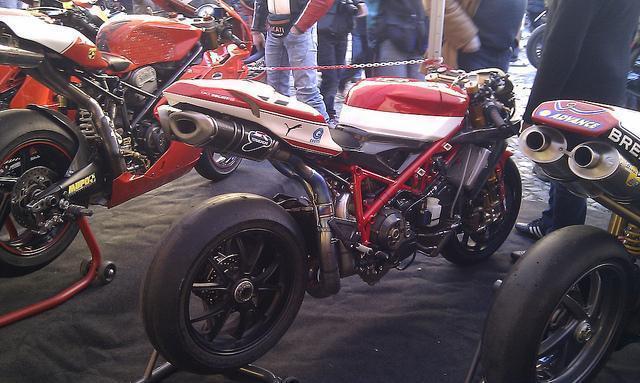What type of vehicle are these?
Answer the question by selecting the correct answer among the 4 following choices.
Options: Truck, motorcycle, helicopter, bicycle. Motorcycle. 